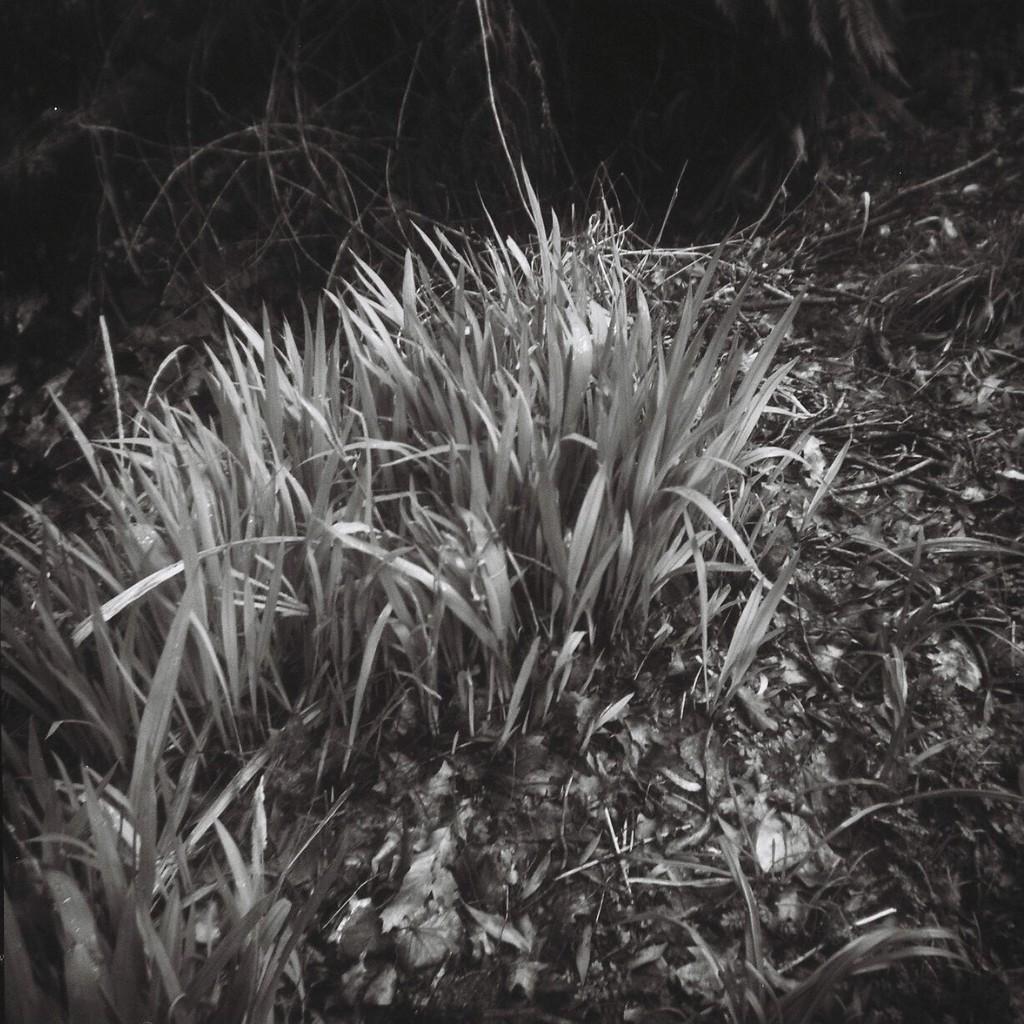Can you describe this image briefly? These are plants. 